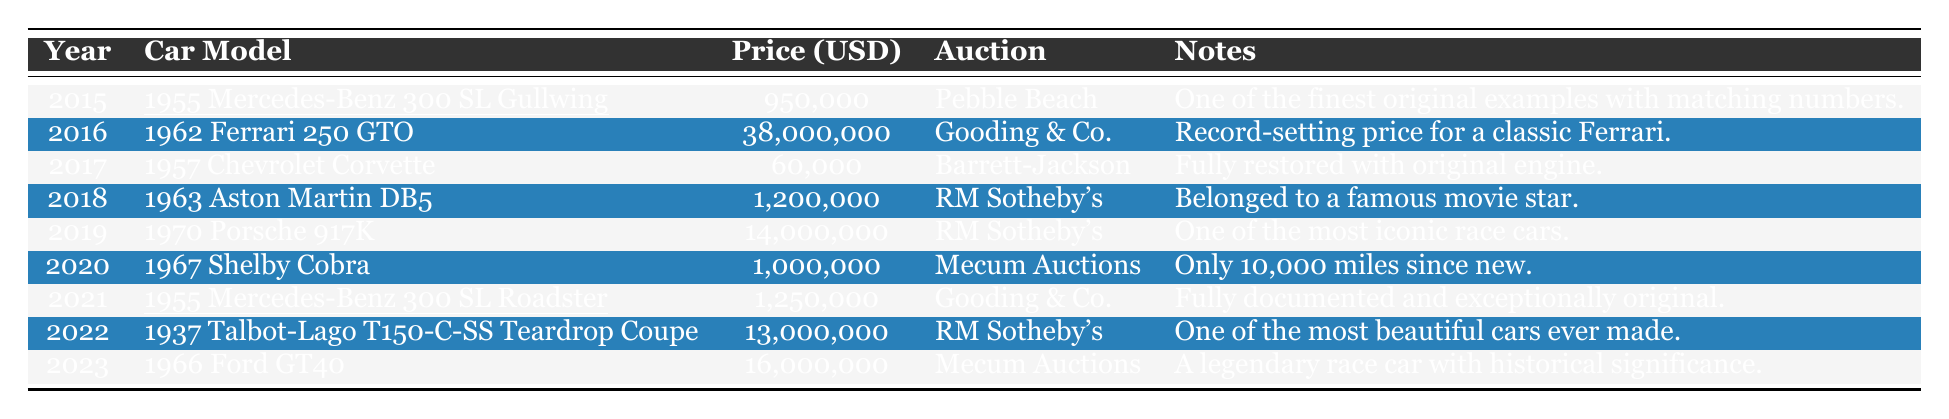What was the auction price of the 1955 Mercedes-Benz 300 SL Gullwing in 2015? The auction price of the 1955 Mercedes-Benz 300 SL Gullwing in 2015 is listed in the table as 950,000 USD.
Answer: 950,000 USD Which car had the highest auction price in the given years? The table shows that the 1962 Ferrari 250 GTO had the highest auction price at 38,000,000 USD in 2016.
Answer: 38,000,000 USD In which year was the 1967 Shelby Cobra auctioned, and what was its price? The table indicates that the 1967 Shelby Cobra was auctioned in 2020, with a price of 1,000,000 USD.
Answer: 2020, 1,000,000 USD What is the total auction price of the cars listed from 2015 to 2023? Summing the auction prices: 950,000 + 38,000,000 + 60,000 + 1,200,000 + 14,000,000 + 1,000,000 + 1,250,000 + 13,000,000 + 16,000,000 results in a total of 85,460,000 USD.
Answer: 85,460,000 USD Was the auction price of the 1955 Mercedes-Benz 300 SL Roadster greater than that of the 1955 Mercedes-Benz 300 SL Gullwing? The auction price of the 1955 Mercedes-Benz 300 SL Roadster was 1,250,000 USD, while the Gullwing was 950,000 USD; therefore, the Roadster’s price is indeed greater.
Answer: Yes What was the average auction price of the vintage cars from 2015 to 2023? The total auction price is 85,460,000 USD for 9 cars, so the average is calculated as 85,460,000 / 9, which equals approximately 9,496,667 USD.
Answer: 9,496,667 USD In how many years did Mercedes-Benz vehicles appear at the auctions, according to the table? The table shows the 1955 Mercedes-Benz 300 SL Gullwing in 2015 and the 1955 Mercedes-Benz 300 SL Roadster in 2021, indicating that Mercedes-Benz vehicles appeared in 2 distinct years.
Answer: 2 years What decade are all the cars in this table from? All the cars listed were produced before the year 1980, indicating they are all from the vintage car category, specifically the mid-20th century or earlier.
Answer: 1960s and 1970s Which auction location hosted the sale of both the 1955 Mercedes-Benz 300 SL Gullwing and the 1955 Mercedes-Benz 300 SL Roadster? The 1955 Mercedes-Benz 300 SL Gullwing was auctioned at Pebble Beach, and the 1955 Mercedes-Benz 300 SL Roadster was auctioned at Gooding & Co.; therefore, they were hosted at different locations.
Answer: No, different locations 